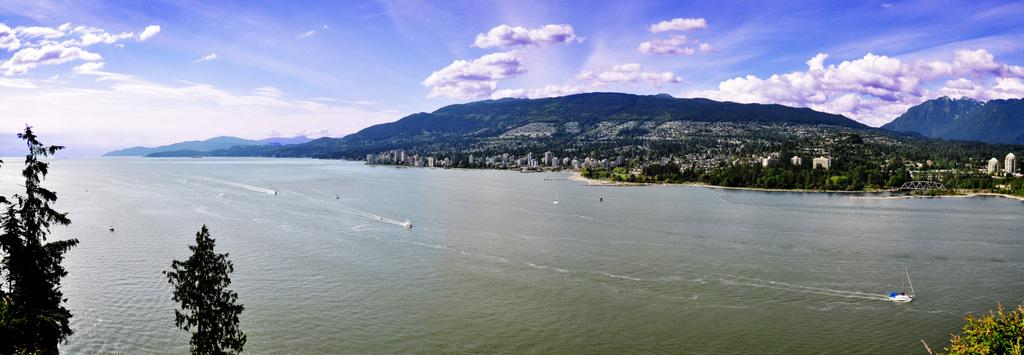What is at the bottom of the image? There is water at the bottom of the image. What is floating on the water in the image? There is a boat in the image. What can be seen in the distance in the image? There are trees and buildings in the background of the image. What is visible at the top of the image? The sky is visible at the top of the image. What type of acoustics can be heard from the boat in the image? There is no information about the acoustics or any sound in the image, as it only shows a boat on water with trees, buildings, and sky in the background. 